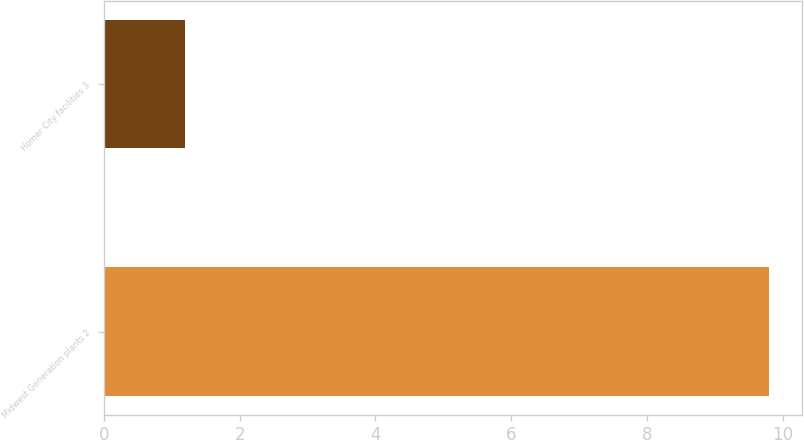<chart> <loc_0><loc_0><loc_500><loc_500><bar_chart><fcel>Midwest Generation plants 2<fcel>Homer City facilities 3<nl><fcel>9.8<fcel>1.2<nl></chart> 